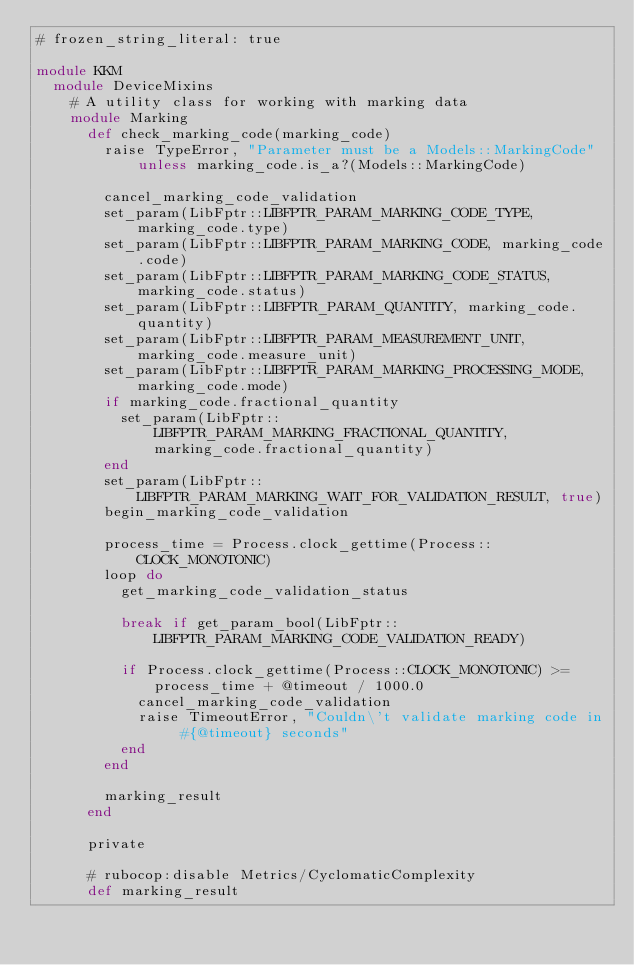Convert code to text. <code><loc_0><loc_0><loc_500><loc_500><_Ruby_># frozen_string_literal: true

module KKM
  module DeviceMixins
    # A utility class for working with marking data
    module Marking
      def check_marking_code(marking_code)
        raise TypeError, "Parameter must be a Models::MarkingCode" unless marking_code.is_a?(Models::MarkingCode)

        cancel_marking_code_validation
        set_param(LibFptr::LIBFPTR_PARAM_MARKING_CODE_TYPE, marking_code.type)
        set_param(LibFptr::LIBFPTR_PARAM_MARKING_CODE, marking_code.code)
        set_param(LibFptr::LIBFPTR_PARAM_MARKING_CODE_STATUS, marking_code.status)
        set_param(LibFptr::LIBFPTR_PARAM_QUANTITY, marking_code.quantity)
        set_param(LibFptr::LIBFPTR_PARAM_MEASUREMENT_UNIT, marking_code.measure_unit)
        set_param(LibFptr::LIBFPTR_PARAM_MARKING_PROCESSING_MODE, marking_code.mode)
        if marking_code.fractional_quantity
          set_param(LibFptr::LIBFPTR_PARAM_MARKING_FRACTIONAL_QUANTITY, marking_code.fractional_quantity)
        end
        set_param(LibFptr::LIBFPTR_PARAM_MARKING_WAIT_FOR_VALIDATION_RESULT, true)
        begin_marking_code_validation

        process_time = Process.clock_gettime(Process::CLOCK_MONOTONIC)
        loop do
          get_marking_code_validation_status

          break if get_param_bool(LibFptr::LIBFPTR_PARAM_MARKING_CODE_VALIDATION_READY)

          if Process.clock_gettime(Process::CLOCK_MONOTONIC) >= process_time + @timeout / 1000.0
            cancel_marking_code_validation
            raise TimeoutError, "Couldn\'t validate marking code in #{@timeout} seconds"
          end
        end

        marking_result
      end

      private

      # rubocop:disable Metrics/CyclomaticComplexity
      def marking_result</code> 